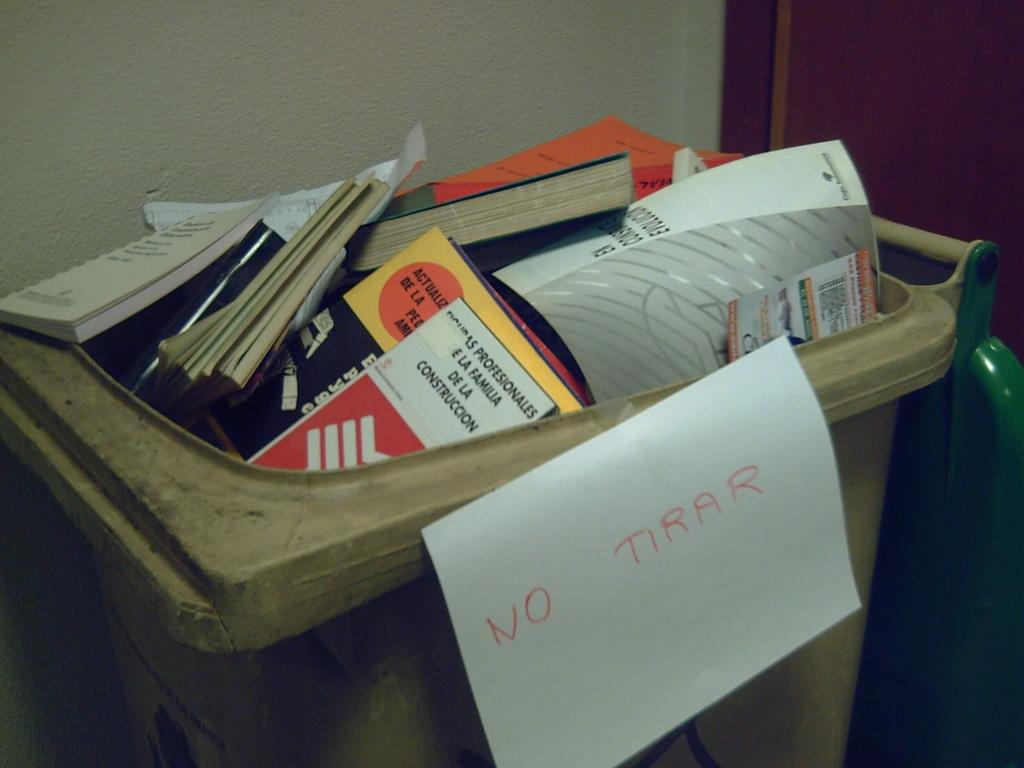Provide a one-sentence caption for the provided image. A trashcan with a sign that says No Tirar. 